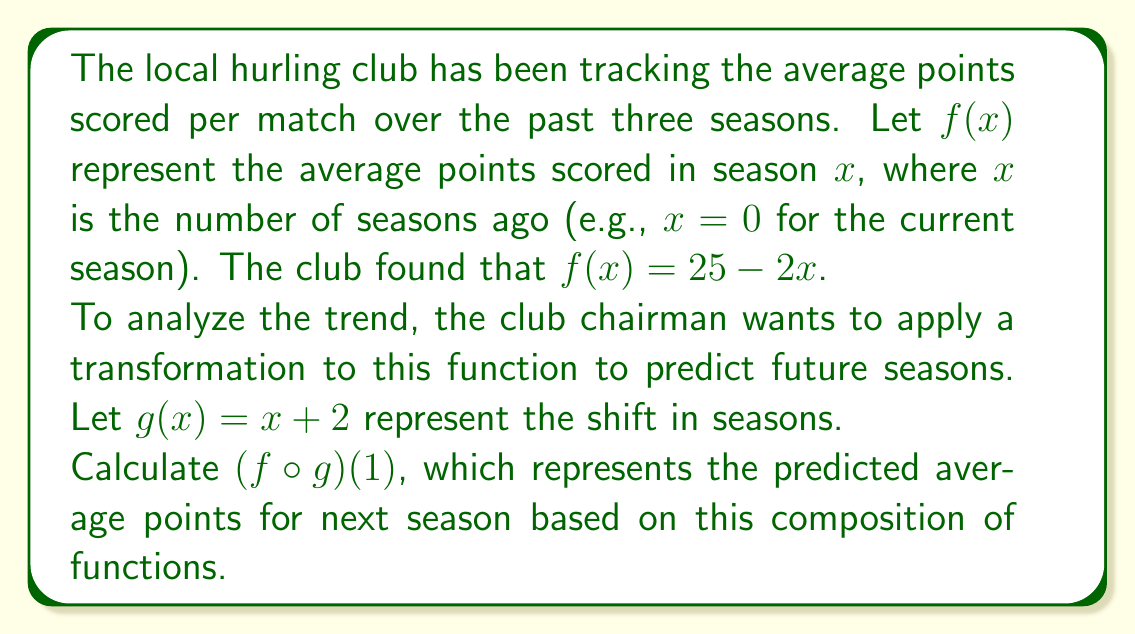Can you solve this math problem? Let's approach this step-by-step:

1) We are given two functions:
   $f(x) = 25 - 2x$
   $g(x) = x + 2$

2) We need to find $(f \circ g)(1)$, which means we first apply $g$ to 1, then apply $f$ to the result.

3) First, let's calculate $g(1)$:
   $g(1) = 1 + 2 = 3$

4) Now, we need to calculate $f(g(1))$, which is equivalent to $f(3)$:
   $f(3) = 25 - 2(3) = 25 - 6 = 19$

5) Therefore, $(f \circ g)(1) = 19$

This means that based on the composition of these functions, the predicted average points for next season is 19.
Answer: 19 points 